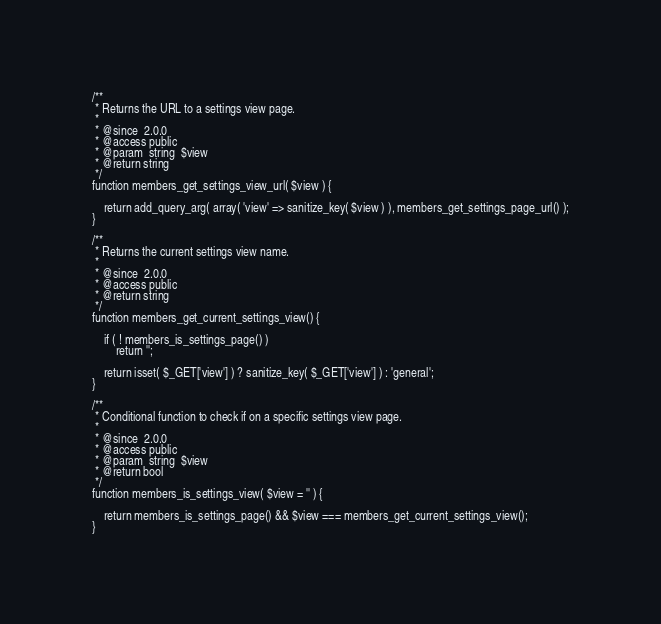Convert code to text. <code><loc_0><loc_0><loc_500><loc_500><_PHP_>/**
 * Returns the URL to a settings view page.
 *
 * @since  2.0.0
 * @access public
 * @param  string  $view
 * @return string
 */
function members_get_settings_view_url( $view ) {

	return add_query_arg( array( 'view' => sanitize_key( $view ) ), members_get_settings_page_url() );
}

/**
 * Returns the current settings view name.
 *
 * @since  2.0.0
 * @access public
 * @return string
 */
function members_get_current_settings_view() {

	if ( ! members_is_settings_page() )
		return '';

	return isset( $_GET['view'] ) ? sanitize_key( $_GET['view'] ) : 'general';
}

/**
 * Conditional function to check if on a specific settings view page.
 *
 * @since  2.0.0
 * @access public
 * @param  string  $view
 * @return bool
 */
function members_is_settings_view( $view = '' ) {

	return members_is_settings_page() && $view === members_get_current_settings_view();
}
</code> 